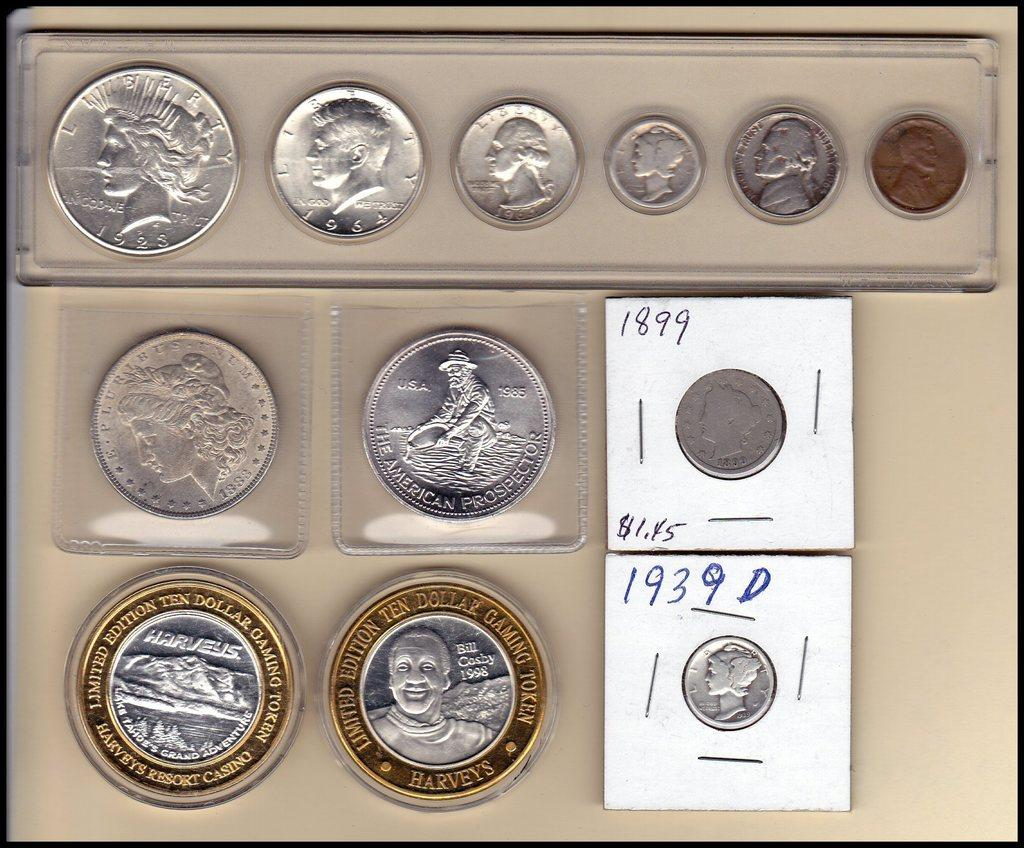<image>
Give a short and clear explanation of the subsequent image. a series of coins included a limited edition ten dollar gaming coin 